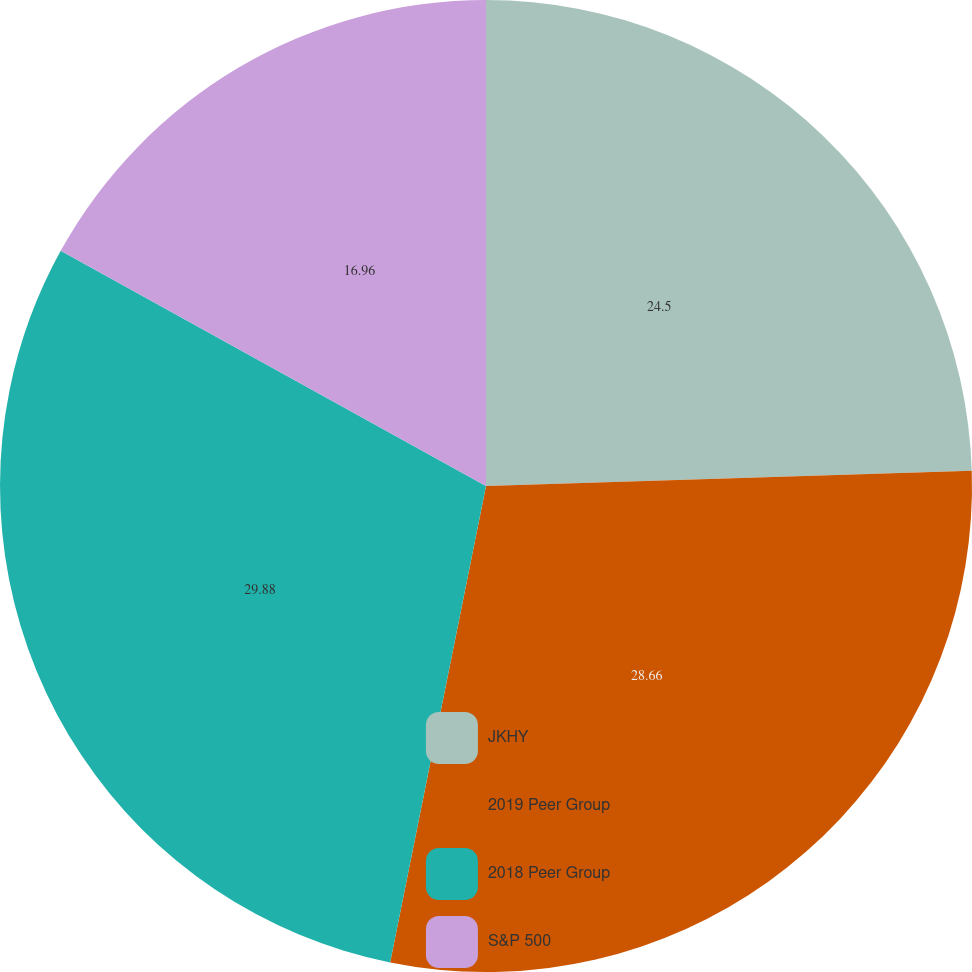Convert chart. <chart><loc_0><loc_0><loc_500><loc_500><pie_chart><fcel>JKHY<fcel>2019 Peer Group<fcel>2018 Peer Group<fcel>S&P 500<nl><fcel>24.5%<fcel>28.66%<fcel>29.88%<fcel>16.96%<nl></chart> 